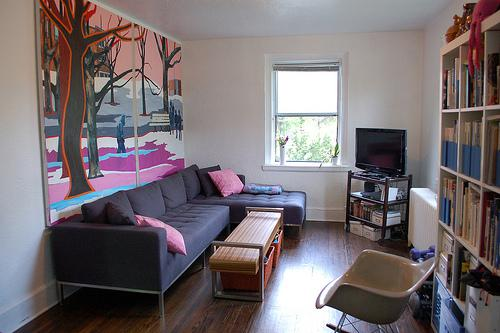Question: what color is the chair?
Choices:
A. Tan.
B. Black.
C. Brown.
D. Grey.
Answer with the letter. Answer: A Question: where was this photo taken?
Choices:
A. Bathroom.
B. Porch.
C. Dining room.
D. Living room.
Answer with the letter. Answer: D Question: what is on tv?
Choices:
A. A game.
B. Cartoons.
C. The news.
D. Nothing.
Answer with the letter. Answer: D 